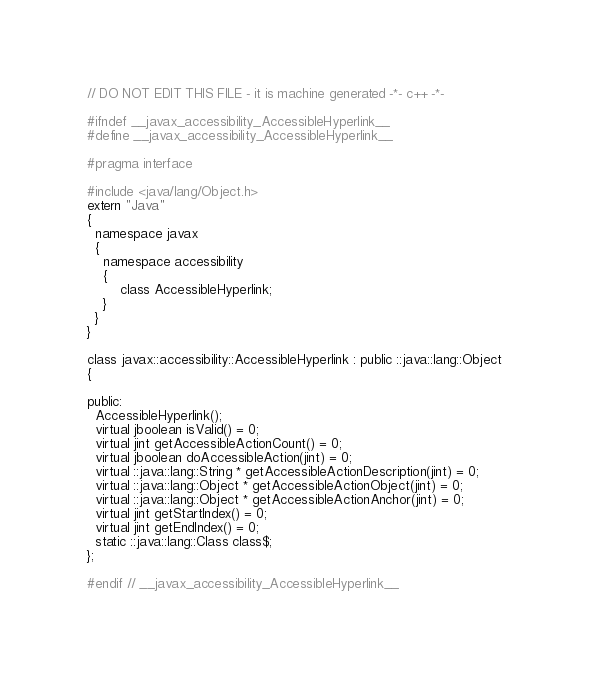<code> <loc_0><loc_0><loc_500><loc_500><_C_>
// DO NOT EDIT THIS FILE - it is machine generated -*- c++ -*-

#ifndef __javax_accessibility_AccessibleHyperlink__
#define __javax_accessibility_AccessibleHyperlink__

#pragma interface

#include <java/lang/Object.h>
extern "Java"
{
  namespace javax
  {
    namespace accessibility
    {
        class AccessibleHyperlink;
    }
  }
}

class javax::accessibility::AccessibleHyperlink : public ::java::lang::Object
{

public:
  AccessibleHyperlink();
  virtual jboolean isValid() = 0;
  virtual jint getAccessibleActionCount() = 0;
  virtual jboolean doAccessibleAction(jint) = 0;
  virtual ::java::lang::String * getAccessibleActionDescription(jint) = 0;
  virtual ::java::lang::Object * getAccessibleActionObject(jint) = 0;
  virtual ::java::lang::Object * getAccessibleActionAnchor(jint) = 0;
  virtual jint getStartIndex() = 0;
  virtual jint getEndIndex() = 0;
  static ::java::lang::Class class$;
};

#endif // __javax_accessibility_AccessibleHyperlink__
</code> 